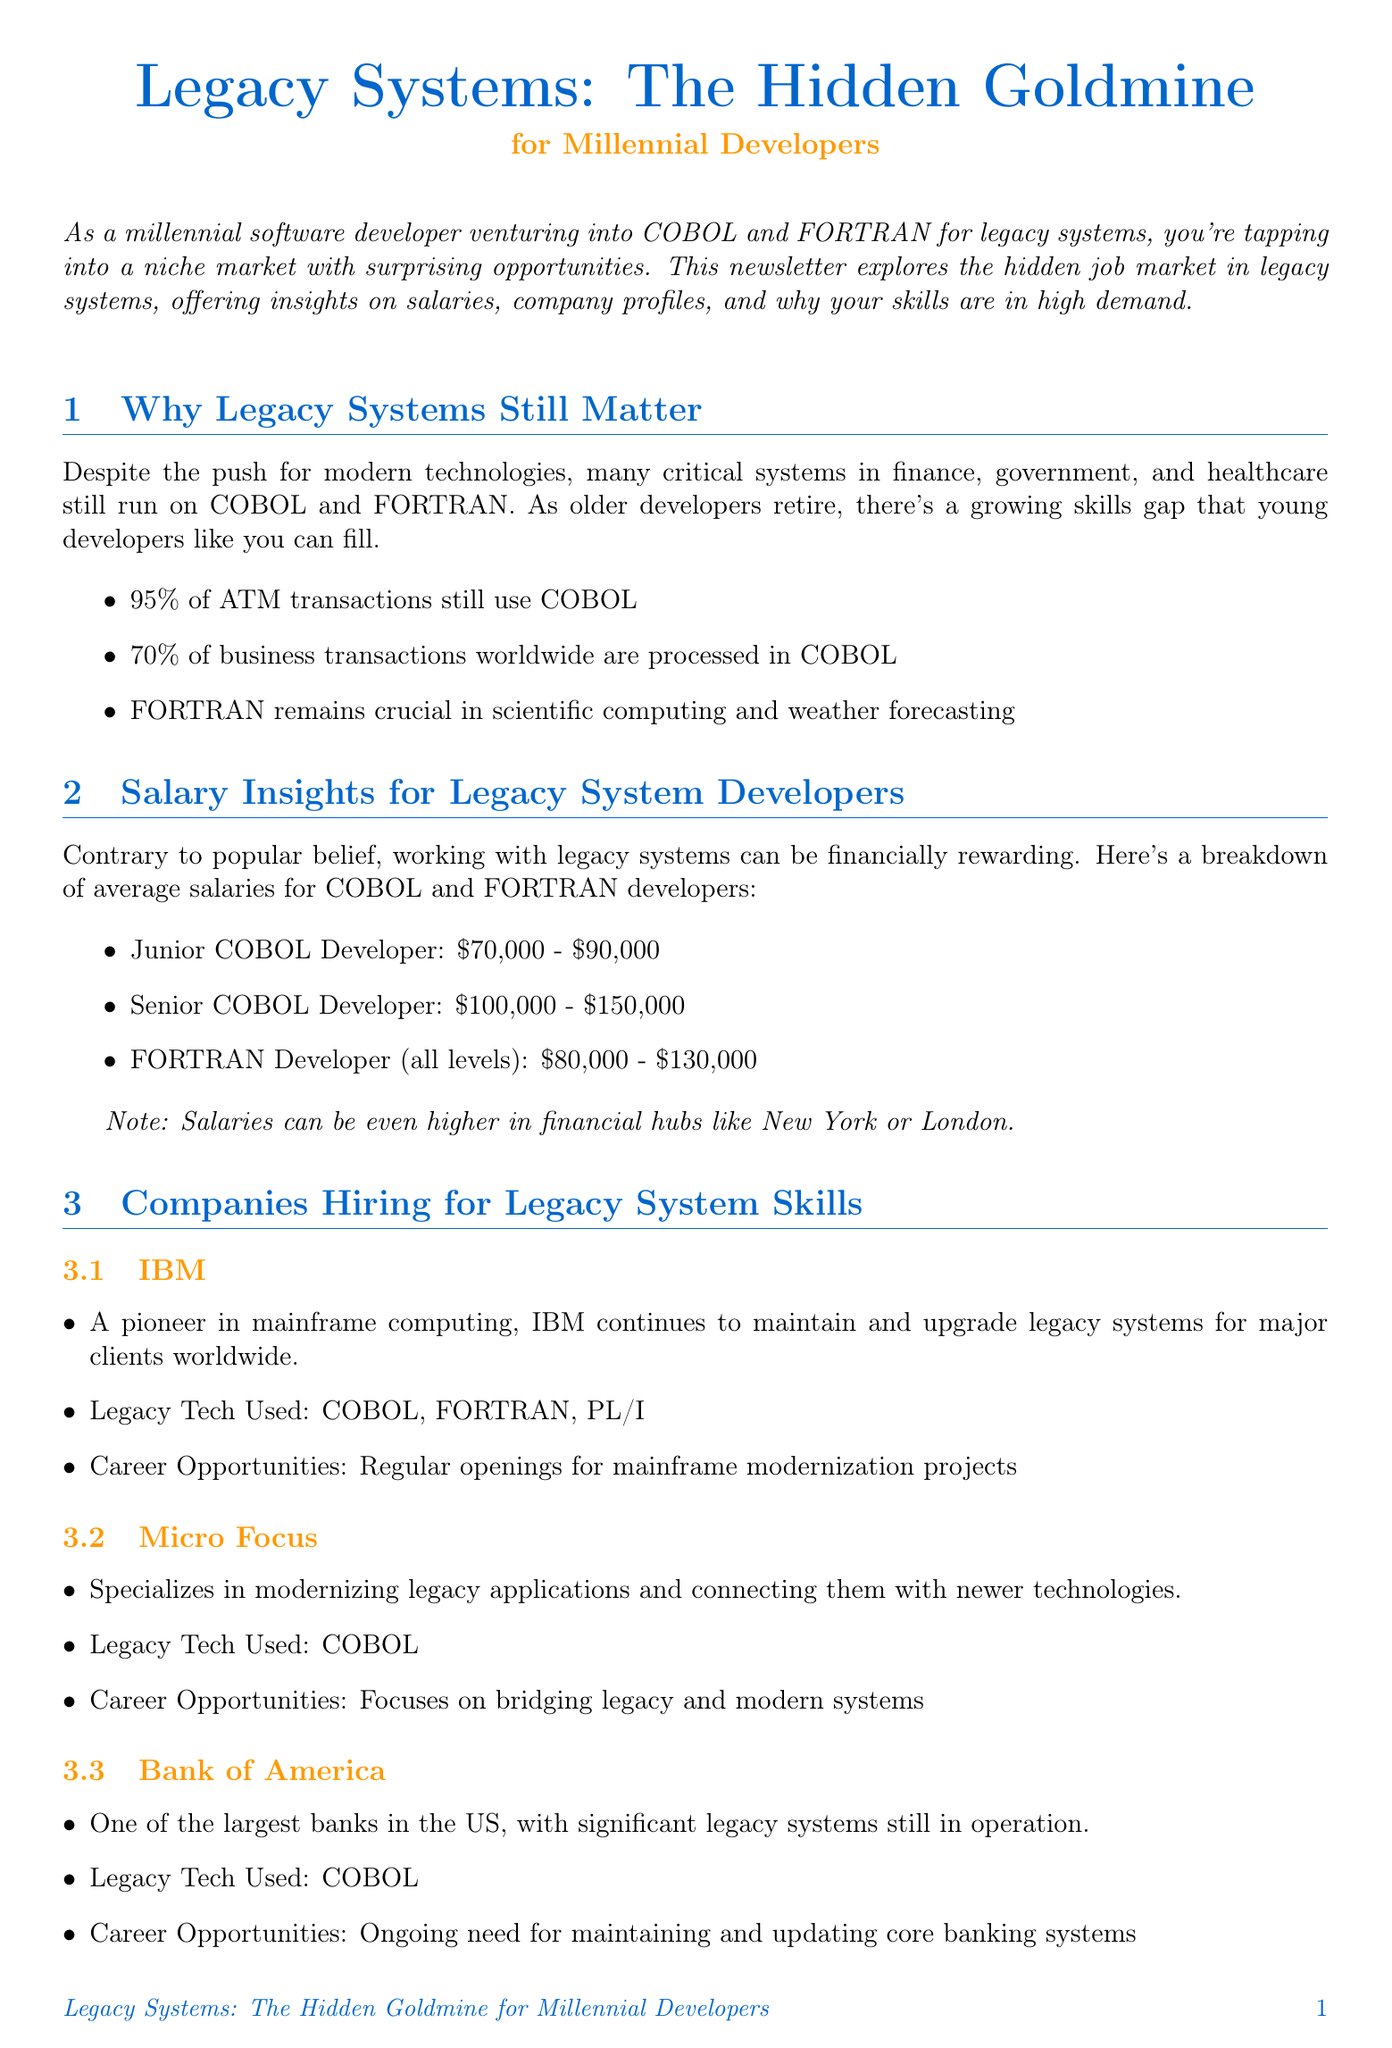what percentage of ATM transactions use COBOL? The document states that 95% of ATM transactions still use COBOL.
Answer: 95% what is the salary range for a Junior COBOL Developer? The document provides the salary range of $70,000 - $90,000 for this position.
Answer: $70,000 - $90,000 which company specializes in modernizing legacy applications? The document mentions Micro Focus as a company that specializes in this area.
Answer: Micro Focus what skills complement legacy system knowledge according to the document? The document lists several skills including Java or C#, Cloud computing platforms, DevOps practices, and API development.
Answer: Java or C#, Cloud computing platforms, DevOps practices, API development which company has a significant demand for maintaining core banking systems? The document identifies Bank of America as having this ongoing need.
Answer: Bank of America what is the average salary for FORTRAN Developers at all levels? The document lists the salary range for FORTRAN Developers as $80,000 - $130,000.
Answer: $80,000 - $130,000 how many key points are listed under "Why Legacy Systems Still Matter"? The document provides three key points in this section.
Answer: 3 what networking channel is associated with IBM-focused user groups? The document mentions SHARE as an IBM-focused user group with events and job postings.
Answer: SHARE 